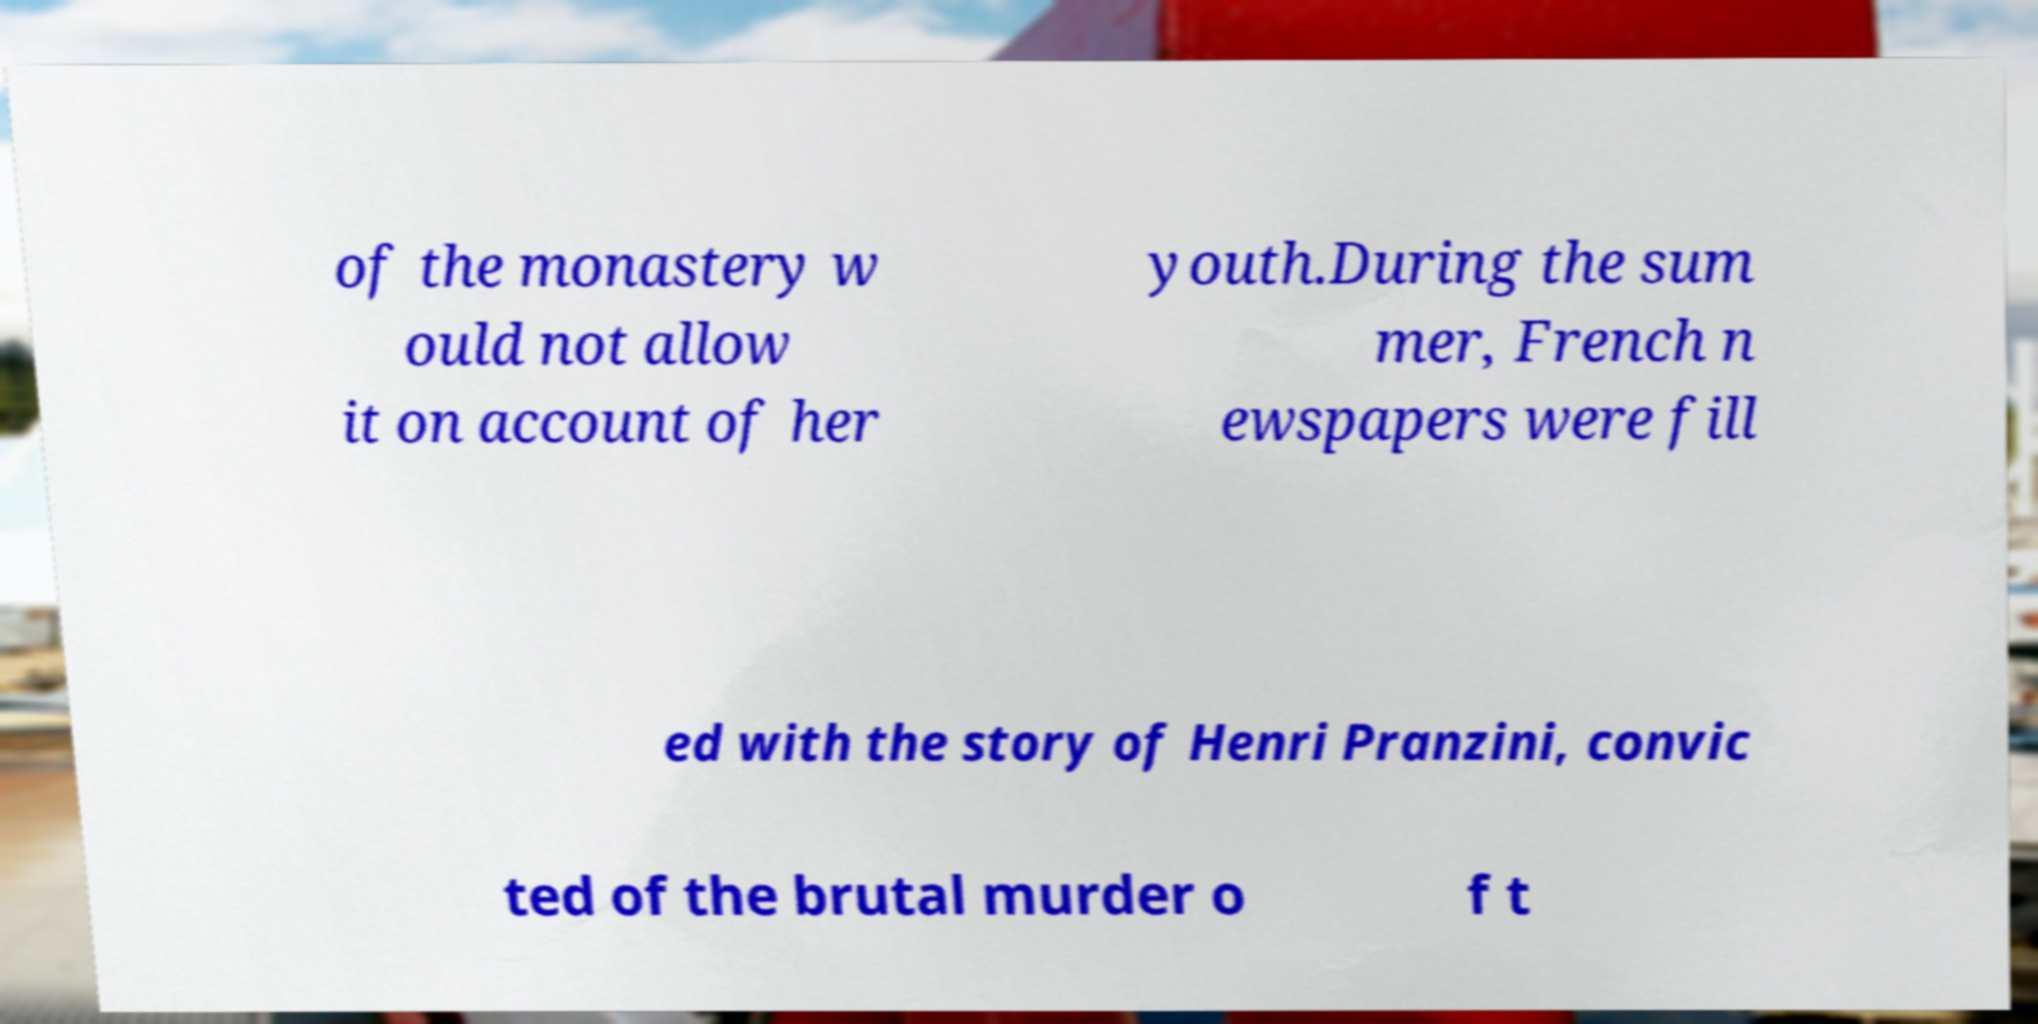For documentation purposes, I need the text within this image transcribed. Could you provide that? of the monastery w ould not allow it on account of her youth.During the sum mer, French n ewspapers were fill ed with the story of Henri Pranzini, convic ted of the brutal murder o f t 